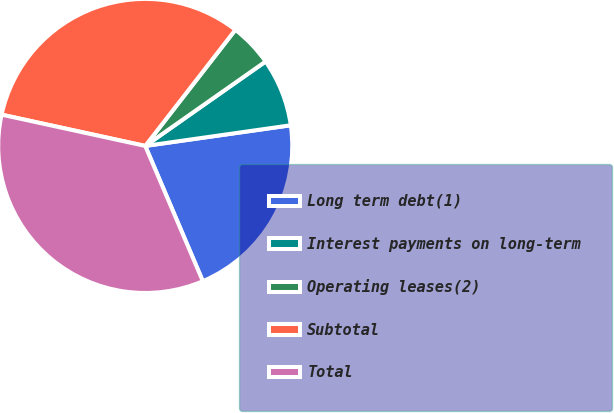<chart> <loc_0><loc_0><loc_500><loc_500><pie_chart><fcel>Long term debt(1)<fcel>Interest payments on long-term<fcel>Operating leases(2)<fcel>Subtotal<fcel>Total<nl><fcel>20.84%<fcel>7.49%<fcel>4.76%<fcel>32.09%<fcel>34.82%<nl></chart> 